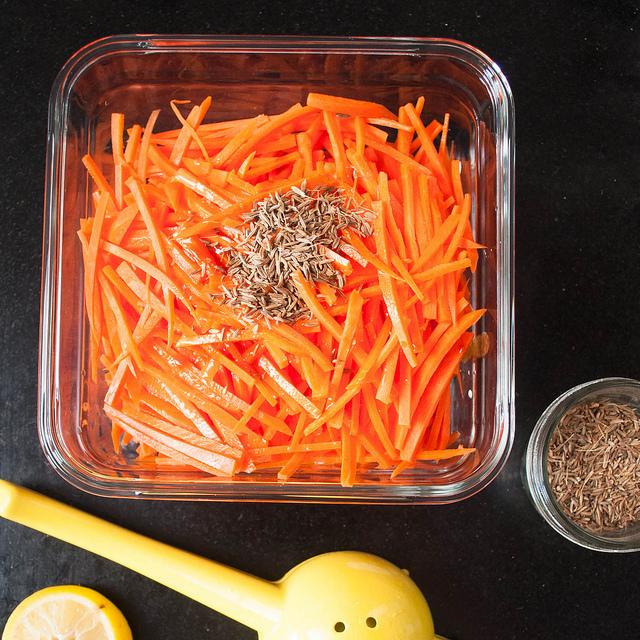Were the carrots sliced by hand or put in a blender?
Write a very short answer. Hand. What geometric shape is the container holding the carrots?
Concise answer only. Square. How many lemons are in the picture?
Be succinct. 1. 